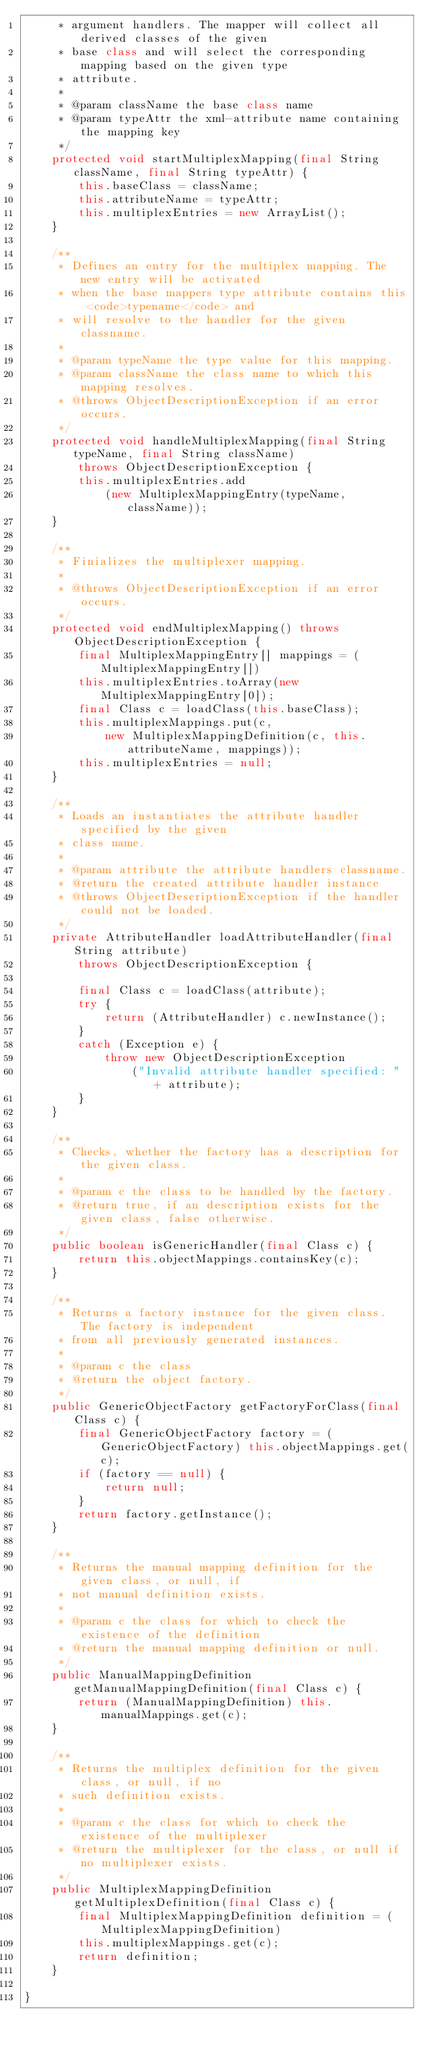Convert code to text. <code><loc_0><loc_0><loc_500><loc_500><_Java_>     * argument handlers. The mapper will collect all derived classes of the given
     * base class and will select the corresponding mapping based on the given type
     * attribute.
     *
     * @param className the base class name
     * @param typeAttr the xml-attribute name containing the mapping key
     */
    protected void startMultiplexMapping(final String className, final String typeAttr) {
        this.baseClass = className;
        this.attributeName = typeAttr;
        this.multiplexEntries = new ArrayList();
    }

    /**
     * Defines an entry for the multiplex mapping. The new entry will be activated
     * when the base mappers type attribute contains this <code>typename</code> and
     * will resolve to the handler for the given classname.
     *
     * @param typeName the type value for this mapping.
     * @param className the class name to which this mapping resolves.
     * @throws ObjectDescriptionException if an error occurs.
     */
    protected void handleMultiplexMapping(final String typeName, final String className)
        throws ObjectDescriptionException {
        this.multiplexEntries.add
            (new MultiplexMappingEntry(typeName, className));
    }

    /**
     * Finializes the multiplexer mapping.
     *
     * @throws ObjectDescriptionException if an error occurs.
     */
    protected void endMultiplexMapping() throws ObjectDescriptionException {
        final MultiplexMappingEntry[] mappings = (MultiplexMappingEntry[])
        this.multiplexEntries.toArray(new MultiplexMappingEntry[0]);
        final Class c = loadClass(this.baseClass);
        this.multiplexMappings.put(c,
            new MultiplexMappingDefinition(c, this.attributeName, mappings));
        this.multiplexEntries = null;
    }

    /**
     * Loads an instantiates the attribute handler specified by the given
     * class name.
     *
     * @param attribute the attribute handlers classname.
     * @return the created attribute handler instance
     * @throws ObjectDescriptionException if the handler could not be loaded.
     */
    private AttributeHandler loadAttributeHandler(final String attribute)
        throws ObjectDescriptionException {

        final Class c = loadClass(attribute);
        try {
            return (AttributeHandler) c.newInstance();
        }
        catch (Exception e) {
            throw new ObjectDescriptionException
                ("Invalid attribute handler specified: " + attribute);
        }
    }

    /**
     * Checks, whether the factory has a description for the given class.
     *
     * @param c the class to be handled by the factory.
     * @return true, if an description exists for the given class, false otherwise.
     */
    public boolean isGenericHandler(final Class c) {
        return this.objectMappings.containsKey(c);
    }

    /**
     * Returns a factory instance for the given class. The factory is independent
     * from all previously generated instances.
     *
     * @param c the class
     * @return the object factory.
     */
    public GenericObjectFactory getFactoryForClass(final Class c) {
        final GenericObjectFactory factory = (GenericObjectFactory) this.objectMappings.get(c);
        if (factory == null) {
            return null;
        }
        return factory.getInstance();
    }

    /**
     * Returns the manual mapping definition for the given class, or null, if
     * not manual definition exists.
     *
     * @param c the class for which to check the existence of the definition
     * @return the manual mapping definition or null.
     */
    public ManualMappingDefinition getManualMappingDefinition(final Class c) {
        return (ManualMappingDefinition) this.manualMappings.get(c);
    }

    /**
     * Returns the multiplex definition for the given class, or null, if no
     * such definition exists.
     *
     * @param c the class for which to check the existence of the multiplexer
     * @return the multiplexer for the class, or null if no multiplexer exists.
     */
    public MultiplexMappingDefinition getMultiplexDefinition(final Class c) {
        final MultiplexMappingDefinition definition = (MultiplexMappingDefinition)
        this.multiplexMappings.get(c);
        return definition;
    }

}
</code> 